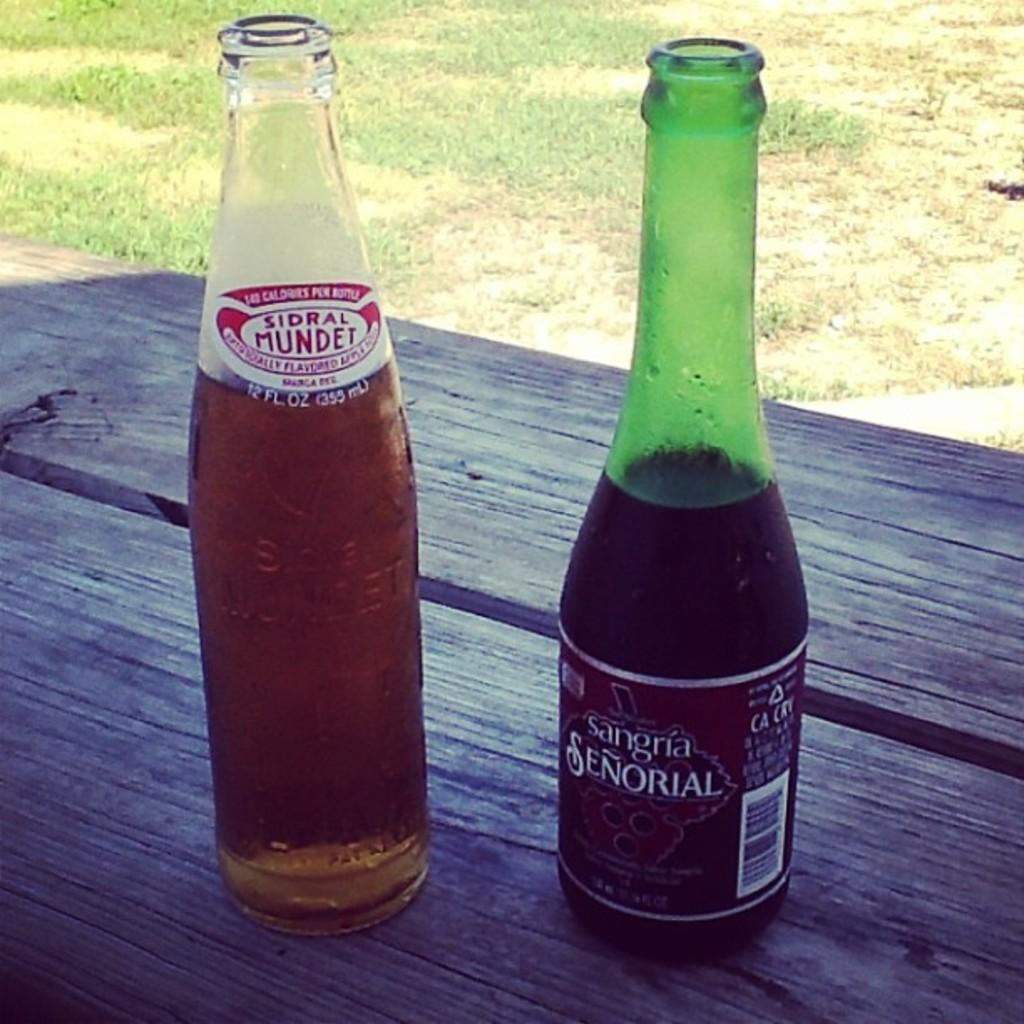<image>
Give a short and clear explanation of the subsequent image. a bottle of Sangria and a Sindral Mundet are on a wood table 